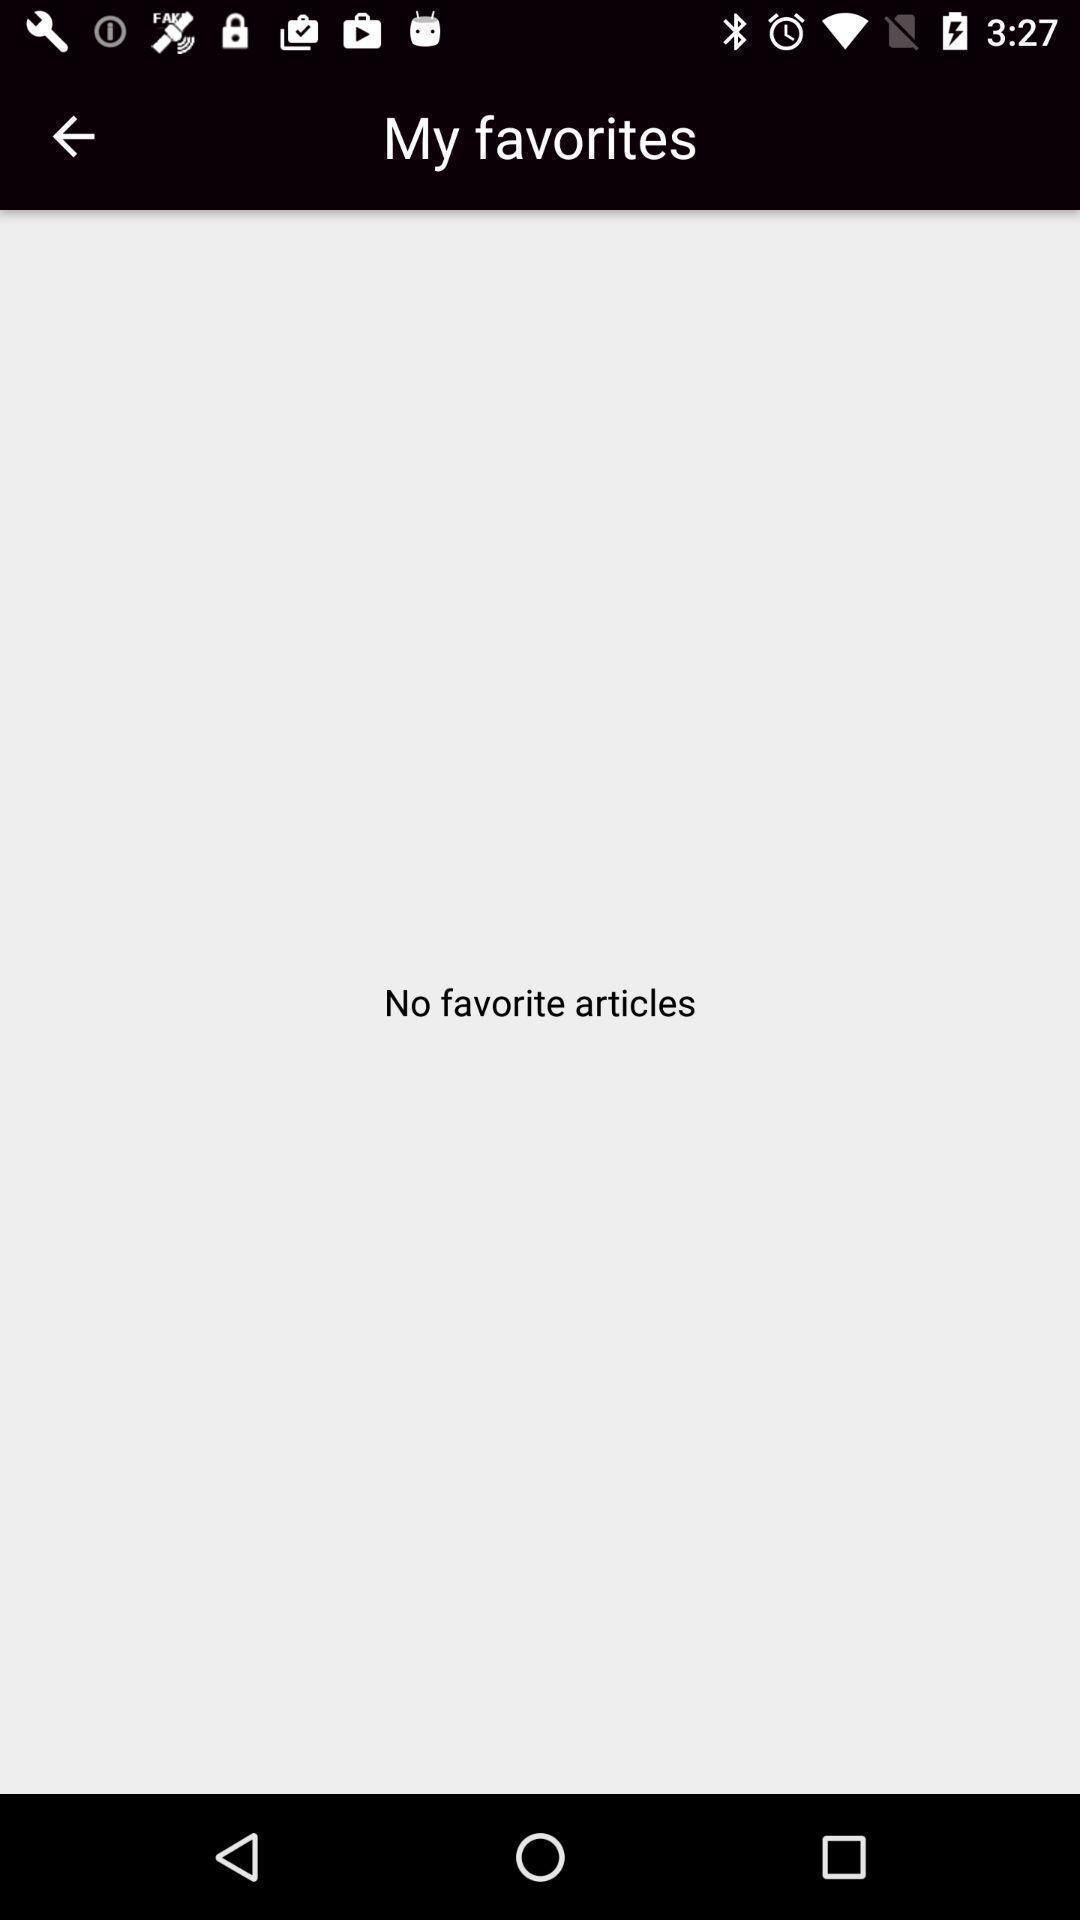What details can you identify in this image? Page showing information of favorites. 